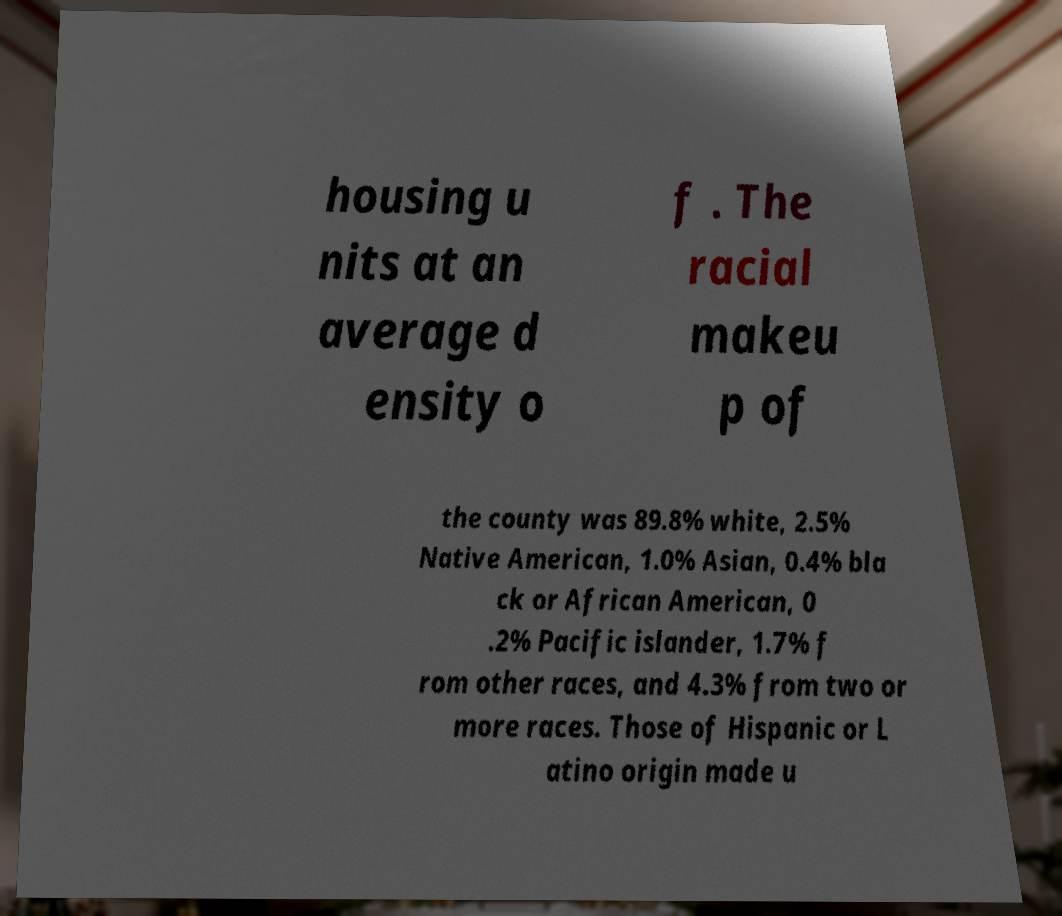For documentation purposes, I need the text within this image transcribed. Could you provide that? housing u nits at an average d ensity o f . The racial makeu p of the county was 89.8% white, 2.5% Native American, 1.0% Asian, 0.4% bla ck or African American, 0 .2% Pacific islander, 1.7% f rom other races, and 4.3% from two or more races. Those of Hispanic or L atino origin made u 